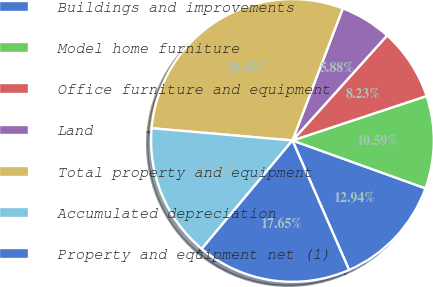<chart> <loc_0><loc_0><loc_500><loc_500><pie_chart><fcel>Buildings and improvements<fcel>Model home furniture<fcel>Office furniture and equipment<fcel>Land<fcel>Total property and equipment<fcel>Accumulated depreciation<fcel>Property and equipment net (1)<nl><fcel>12.94%<fcel>10.59%<fcel>8.23%<fcel>5.88%<fcel>29.42%<fcel>15.29%<fcel>17.65%<nl></chart> 